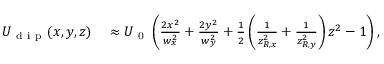Convert formula to latex. <formula><loc_0><loc_0><loc_500><loc_500>\begin{array} { r l } { U _ { d i p } ( x , y , z ) } & \approx U _ { 0 } \left ( \frac { 2 x ^ { 2 } } { w _ { x } ^ { 2 } } + \frac { 2 y ^ { 2 } } { w _ { y } ^ { 2 } } + \frac { 1 } { 2 } \left ( \frac { 1 } { z _ { R , x } ^ { 2 } } + \frac { 1 } { z _ { R , y } ^ { 2 } } \right ) z ^ { 2 } - 1 \right ) , } \end{array}</formula> 